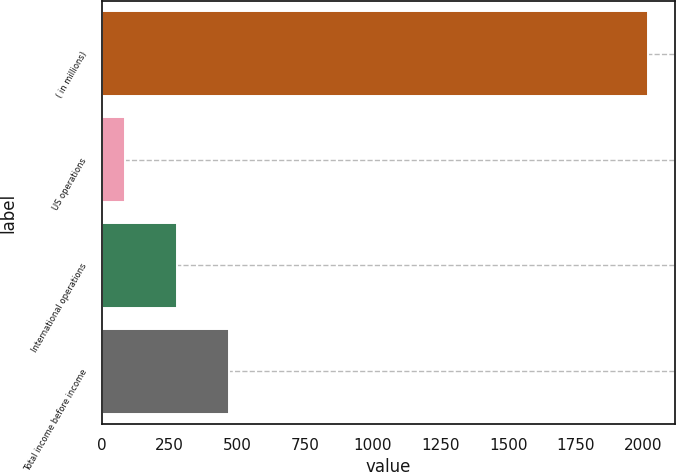Convert chart. <chart><loc_0><loc_0><loc_500><loc_500><bar_chart><fcel>( in millions)<fcel>US operations<fcel>International operations<fcel>Total income before income<nl><fcel>2016<fcel>84.5<fcel>277.65<fcel>470.8<nl></chart> 